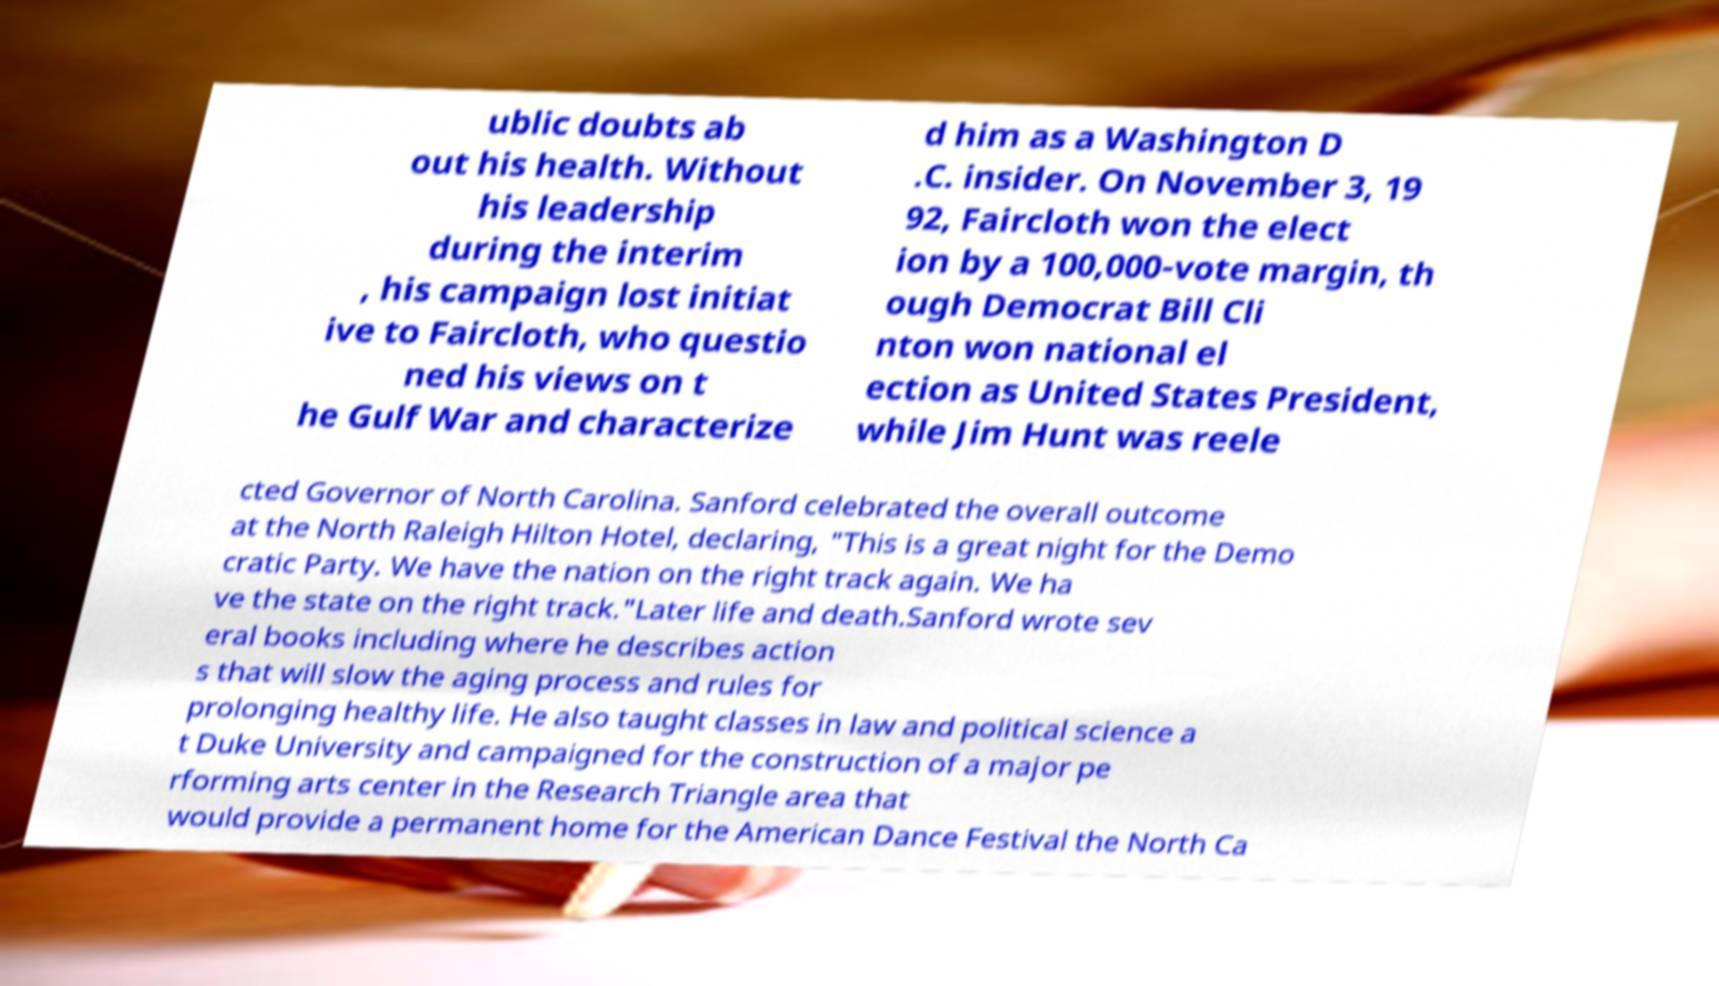What messages or text are displayed in this image? I need them in a readable, typed format. ublic doubts ab out his health. Without his leadership during the interim , his campaign lost initiat ive to Faircloth, who questio ned his views on t he Gulf War and characterize d him as a Washington D .C. insider. On November 3, 19 92, Faircloth won the elect ion by a 100,000-vote margin, th ough Democrat Bill Cli nton won national el ection as United States President, while Jim Hunt was reele cted Governor of North Carolina. Sanford celebrated the overall outcome at the North Raleigh Hilton Hotel, declaring, "This is a great night for the Demo cratic Party. We have the nation on the right track again. We ha ve the state on the right track."Later life and death.Sanford wrote sev eral books including where he describes action s that will slow the aging process and rules for prolonging healthy life. He also taught classes in law and political science a t Duke University and campaigned for the construction of a major pe rforming arts center in the Research Triangle area that would provide a permanent home for the American Dance Festival the North Ca 